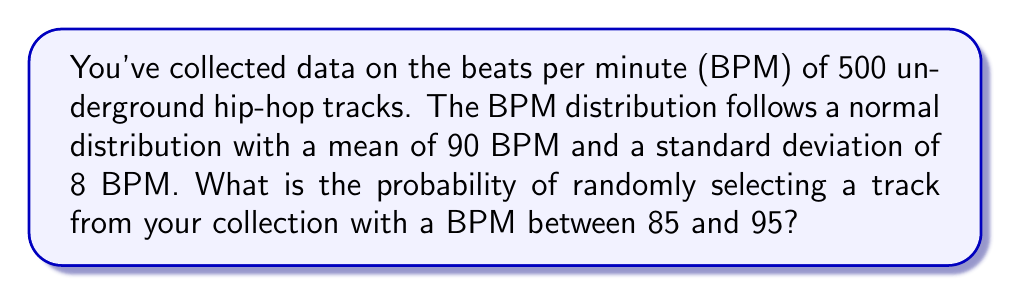Help me with this question. To solve this problem, we'll use the properties of the normal distribution and the concept of z-scores.

Step 1: Identify the given information
- Mean (μ) = 90 BPM
- Standard deviation (σ) = 8 BPM
- We want to find P(85 < X < 95)

Step 2: Calculate the z-scores for the lower and upper bounds
Lower bound: $z_1 = \frac{85 - 90}{8} = -0.625$
Upper bound: $z_2 = \frac{95 - 90}{8} = 0.625$

Step 3: Use the standard normal distribution table or a calculator to find the area under the curve between these z-scores

The probability is equal to the area between $z_1$ and $z_2$:
$P(85 < X < 95) = P(-0.625 < Z < 0.625)$

Using a standard normal distribution table or calculator:
$P(Z < 0.625) - P(Z < -0.625) = 0.7340 - 0.2660 = 0.4680$

Step 4: Convert the result to a percentage
0.4680 * 100 = 46.80%

Therefore, the probability of randomly selecting a track with a BPM between 85 and 95 is approximately 46.80%.
Answer: 46.80% 